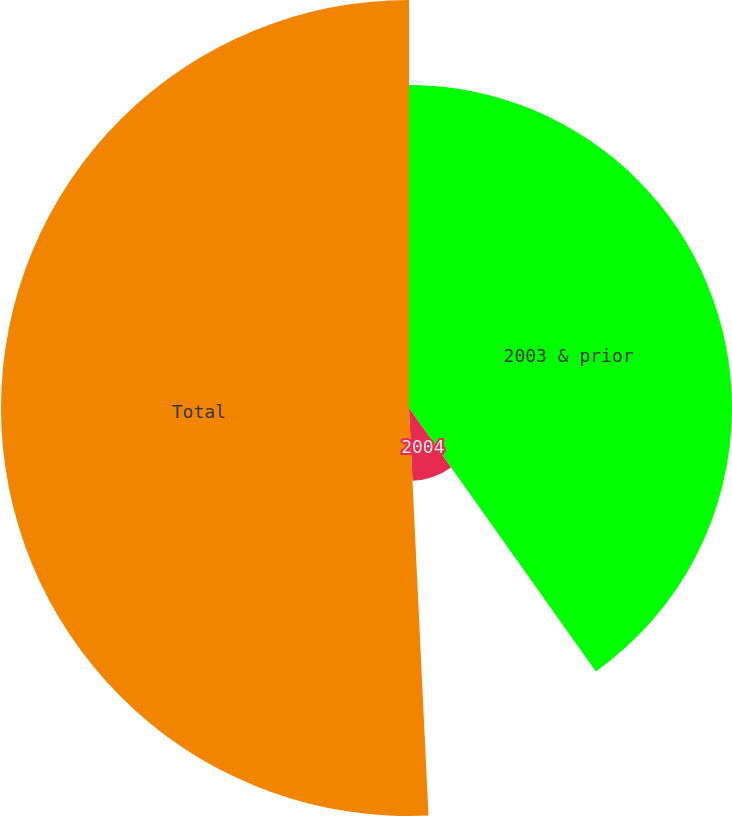<chart> <loc_0><loc_0><loc_500><loc_500><pie_chart><fcel>2003 & prior<fcel>2004<fcel>Total<nl><fcel>40.18%<fcel>9.06%<fcel>50.76%<nl></chart> 